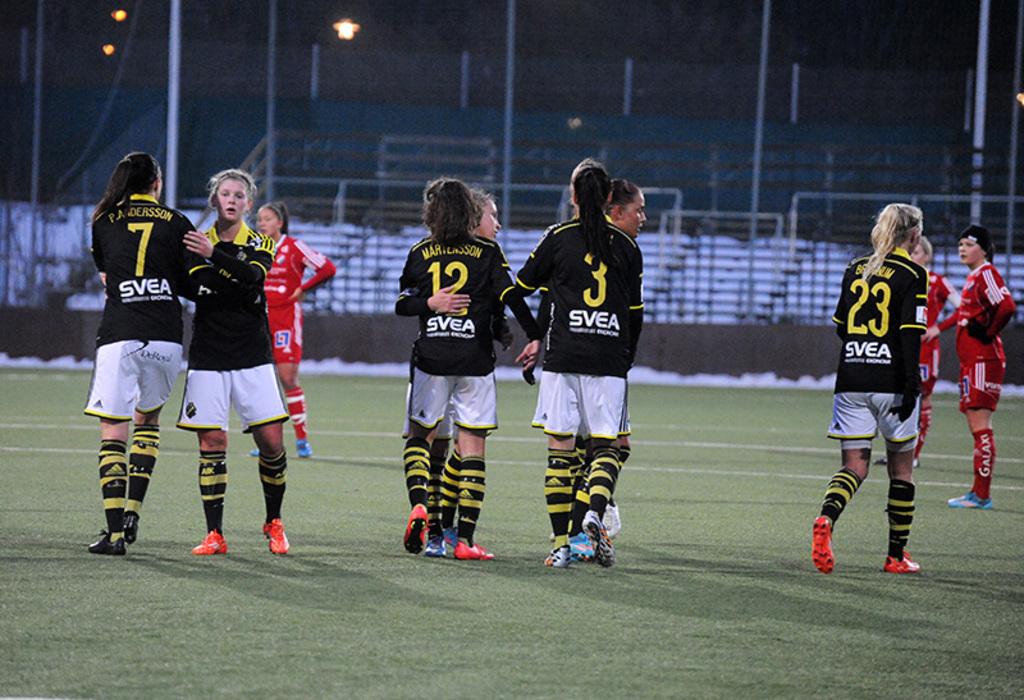What number is the player on the far left?
Your answer should be very brief. 7. 